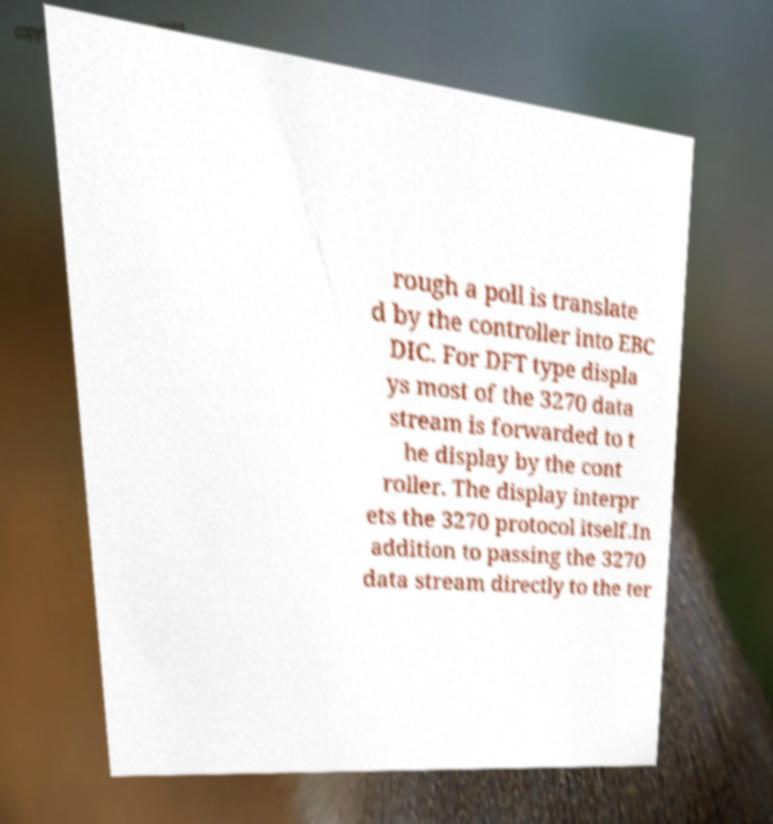Could you assist in decoding the text presented in this image and type it out clearly? rough a poll is translate d by the controller into EBC DIC. For DFT type displa ys most of the 3270 data stream is forwarded to t he display by the cont roller. The display interpr ets the 3270 protocol itself.In addition to passing the 3270 data stream directly to the ter 